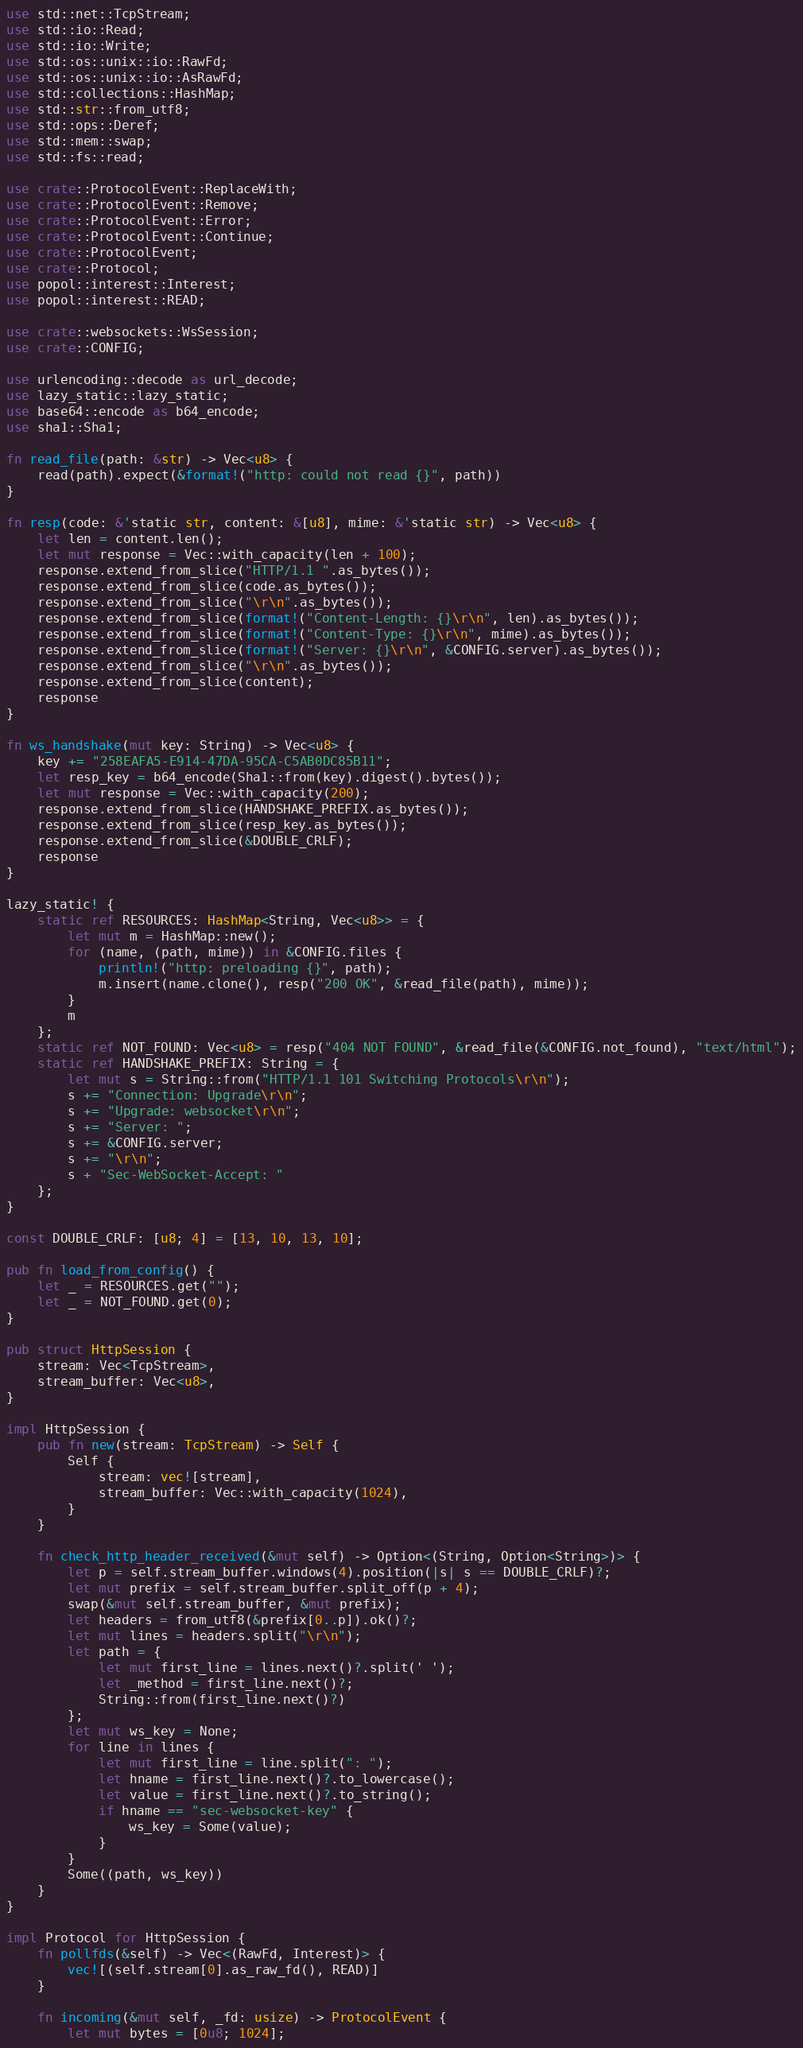<code> <loc_0><loc_0><loc_500><loc_500><_Rust_>use std::net::TcpStream;
use std::io::Read;
use std::io::Write;
use std::os::unix::io::RawFd;
use std::os::unix::io::AsRawFd;
use std::collections::HashMap;
use std::str::from_utf8;
use std::ops::Deref;
use std::mem::swap;
use std::fs::read;

use crate::ProtocolEvent::ReplaceWith;
use crate::ProtocolEvent::Remove;
use crate::ProtocolEvent::Error;
use crate::ProtocolEvent::Continue;
use crate::ProtocolEvent;
use crate::Protocol;
use popol::interest::Interest;
use popol::interest::READ;

use crate::websockets::WsSession;
use crate::CONFIG;

use urlencoding::decode as url_decode;
use lazy_static::lazy_static;
use base64::encode as b64_encode;
use sha1::Sha1;

fn read_file(path: &str) -> Vec<u8> {
	read(path).expect(&format!("http: could not read {}", path))
}

fn resp(code: &'static str, content: &[u8], mime: &'static str) -> Vec<u8> {
	let len = content.len();
	let mut response = Vec::with_capacity(len + 100);
	response.extend_from_slice("HTTP/1.1 ".as_bytes());
	response.extend_from_slice(code.as_bytes());
	response.extend_from_slice("\r\n".as_bytes());
	response.extend_from_slice(format!("Content-Length: {}\r\n", len).as_bytes());
	response.extend_from_slice(format!("Content-Type: {}\r\n", mime).as_bytes());
	response.extend_from_slice(format!("Server: {}\r\n", &CONFIG.server).as_bytes());
	response.extend_from_slice("\r\n".as_bytes());
	response.extend_from_slice(content);
	response
}

fn ws_handshake(mut key: String) -> Vec<u8> {
	key += "258EAFA5-E914-47DA-95CA-C5AB0DC85B11";
	let resp_key = b64_encode(Sha1::from(key).digest().bytes());
	let mut response = Vec::with_capacity(200);
	response.extend_from_slice(HANDSHAKE_PREFIX.as_bytes());
	response.extend_from_slice(resp_key.as_bytes());
	response.extend_from_slice(&DOUBLE_CRLF);
	response
}

lazy_static! {
	static ref RESOURCES: HashMap<String, Vec<u8>> = {
		let mut m = HashMap::new();
		for (name, (path, mime)) in &CONFIG.files {
			println!("http: preloading {}", path);
			m.insert(name.clone(), resp("200 OK", &read_file(path), mime));
		}
		m
	};
	static ref NOT_FOUND: Vec<u8> = resp("404 NOT FOUND", &read_file(&CONFIG.not_found), "text/html");
	static ref HANDSHAKE_PREFIX: String = {
		let mut s = String::from("HTTP/1.1 101 Switching Protocols\r\n");
		s += "Connection: Upgrade\r\n";
		s += "Upgrade: websocket\r\n";
		s += "Server: ";
		s += &CONFIG.server;
		s += "\r\n";
		s + "Sec-WebSocket-Accept: "
	};
}

const DOUBLE_CRLF: [u8; 4] = [13, 10, 13, 10];

pub fn load_from_config() {
	let _ = RESOURCES.get("");
	let _ = NOT_FOUND.get(0);
}

pub struct HttpSession {
	stream: Vec<TcpStream>,
	stream_buffer: Vec<u8>,
}

impl HttpSession {
	pub fn new(stream: TcpStream) -> Self {
		Self {
			stream: vec![stream],
			stream_buffer: Vec::with_capacity(1024),
		}
	}

	fn check_http_header_received(&mut self) -> Option<(String, Option<String>)> {
		let p = self.stream_buffer.windows(4).position(|s| s == DOUBLE_CRLF)?;
		let mut prefix = self.stream_buffer.split_off(p + 4);
		swap(&mut self.stream_buffer, &mut prefix);
		let headers = from_utf8(&prefix[0..p]).ok()?;
		let mut lines = headers.split("\r\n");
		let path = {
			let mut first_line = lines.next()?.split(' ');
			let _method = first_line.next()?;
			String::from(first_line.next()?)
		};
		let mut ws_key = None;
		for line in lines {
			let mut first_line = line.split(": ");
			let hname = first_line.next()?.to_lowercase();
			let value = first_line.next()?.to_string();
			if hname == "sec-websocket-key" {
				ws_key = Some(value);
			}
		}
		Some((path, ws_key))
	}
}

impl Protocol for HttpSession {
	fn pollfds(&self) -> Vec<(RawFd, Interest)> {
		vec![(self.stream[0].as_raw_fd(), READ)]
	}

	fn incoming(&mut self, _fd: usize) -> ProtocolEvent {
		let mut bytes = [0u8; 1024];</code> 